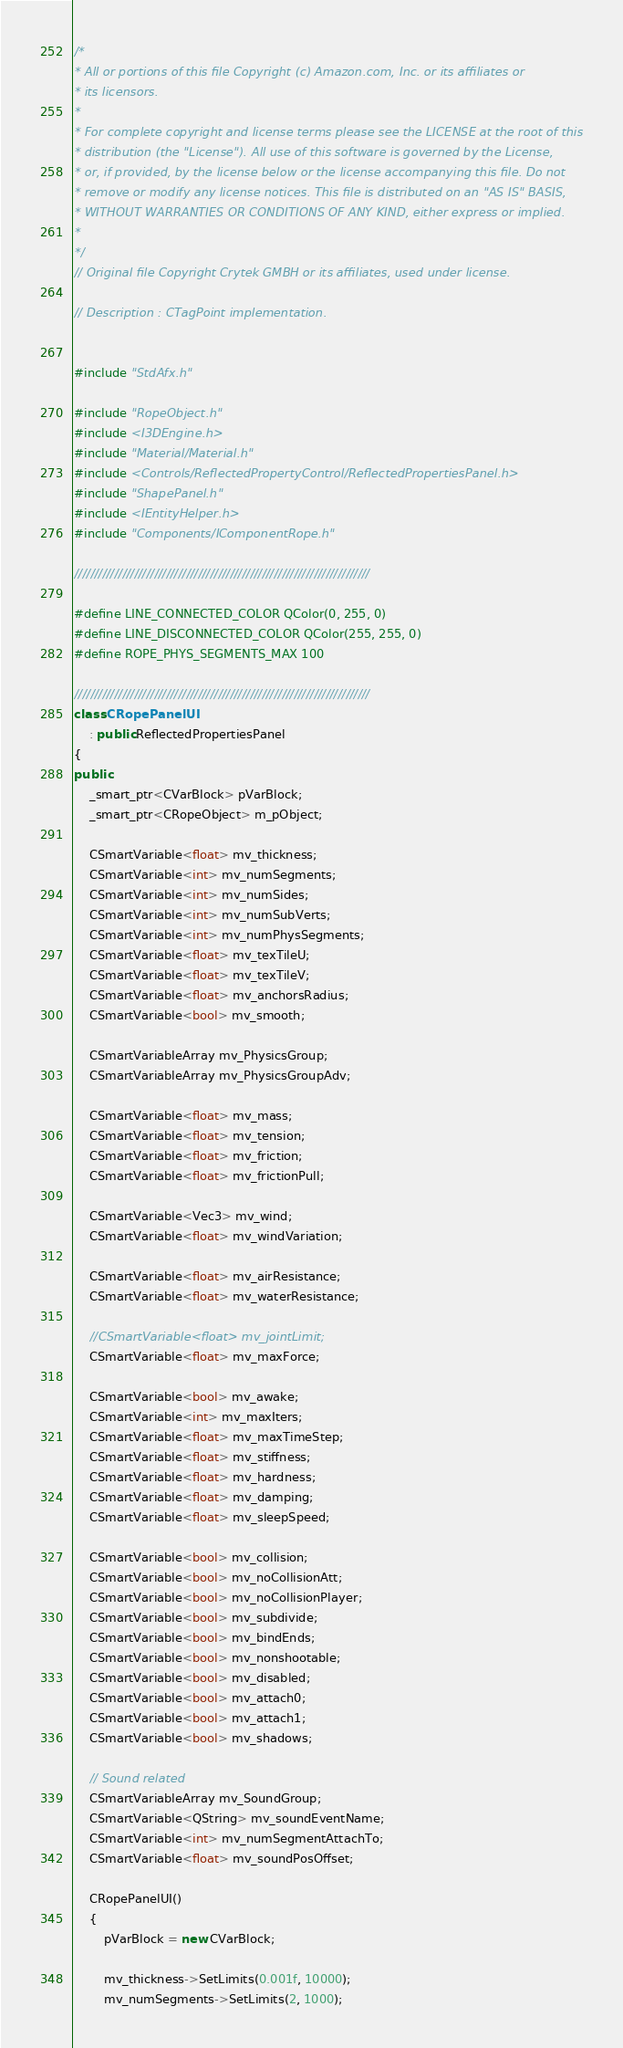<code> <loc_0><loc_0><loc_500><loc_500><_C++_>/*
* All or portions of this file Copyright (c) Amazon.com, Inc. or its affiliates or
* its licensors.
*
* For complete copyright and license terms please see the LICENSE at the root of this
* distribution (the "License"). All use of this software is governed by the License,
* or, if provided, by the license below or the license accompanying this file. Do not
* remove or modify any license notices. This file is distributed on an "AS IS" BASIS,
* WITHOUT WARRANTIES OR CONDITIONS OF ANY KIND, either express or implied.
*
*/
// Original file Copyright Crytek GMBH or its affiliates, used under license.

// Description : CTagPoint implementation.


#include "StdAfx.h"

#include "RopeObject.h"
#include <I3DEngine.h>
#include "Material/Material.h"
#include <Controls/ReflectedPropertyControl/ReflectedPropertiesPanel.h>
#include "ShapePanel.h"
#include <IEntityHelper.h>
#include "Components/IComponentRope.h"

//////////////////////////////////////////////////////////////////////////

#define LINE_CONNECTED_COLOR QColor(0, 255, 0)
#define LINE_DISCONNECTED_COLOR QColor(255, 255, 0)
#define ROPE_PHYS_SEGMENTS_MAX 100

//////////////////////////////////////////////////////////////////////////
class CRopePanelUI
    : public ReflectedPropertiesPanel
{
public:
    _smart_ptr<CVarBlock> pVarBlock;
    _smart_ptr<CRopeObject> m_pObject;

    CSmartVariable<float> mv_thickness;
    CSmartVariable<int> mv_numSegments;
    CSmartVariable<int> mv_numSides;
    CSmartVariable<int> mv_numSubVerts;
    CSmartVariable<int> mv_numPhysSegments;
    CSmartVariable<float> mv_texTileU;
    CSmartVariable<float> mv_texTileV;
    CSmartVariable<float> mv_anchorsRadius;
    CSmartVariable<bool> mv_smooth;

    CSmartVariableArray mv_PhysicsGroup;
    CSmartVariableArray mv_PhysicsGroupAdv;

    CSmartVariable<float> mv_mass;
    CSmartVariable<float> mv_tension;
    CSmartVariable<float> mv_friction;
    CSmartVariable<float> mv_frictionPull;

    CSmartVariable<Vec3> mv_wind;
    CSmartVariable<float> mv_windVariation;

    CSmartVariable<float> mv_airResistance;
    CSmartVariable<float> mv_waterResistance;

    //CSmartVariable<float> mv_jointLimit;
    CSmartVariable<float> mv_maxForce;

    CSmartVariable<bool> mv_awake;
    CSmartVariable<int> mv_maxIters;
    CSmartVariable<float> mv_maxTimeStep;
    CSmartVariable<float> mv_stiffness;
    CSmartVariable<float> mv_hardness;
    CSmartVariable<float> mv_damping;
    CSmartVariable<float> mv_sleepSpeed;

    CSmartVariable<bool> mv_collision;
    CSmartVariable<bool> mv_noCollisionAtt;
    CSmartVariable<bool> mv_noCollisionPlayer;
    CSmartVariable<bool> mv_subdivide;
    CSmartVariable<bool> mv_bindEnds;
    CSmartVariable<bool> mv_nonshootable;
    CSmartVariable<bool> mv_disabled;
    CSmartVariable<bool> mv_attach0;
    CSmartVariable<bool> mv_attach1;
    CSmartVariable<bool> mv_shadows;

    // Sound related
    CSmartVariableArray mv_SoundGroup;
    CSmartVariable<QString> mv_soundEventName;
    CSmartVariable<int> mv_numSegmentAttachTo;
    CSmartVariable<float> mv_soundPosOffset;

    CRopePanelUI()
    {
        pVarBlock = new CVarBlock;

        mv_thickness->SetLimits(0.001f, 10000);
        mv_numSegments->SetLimits(2, 1000);</code> 